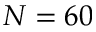<formula> <loc_0><loc_0><loc_500><loc_500>N = 6 0</formula> 